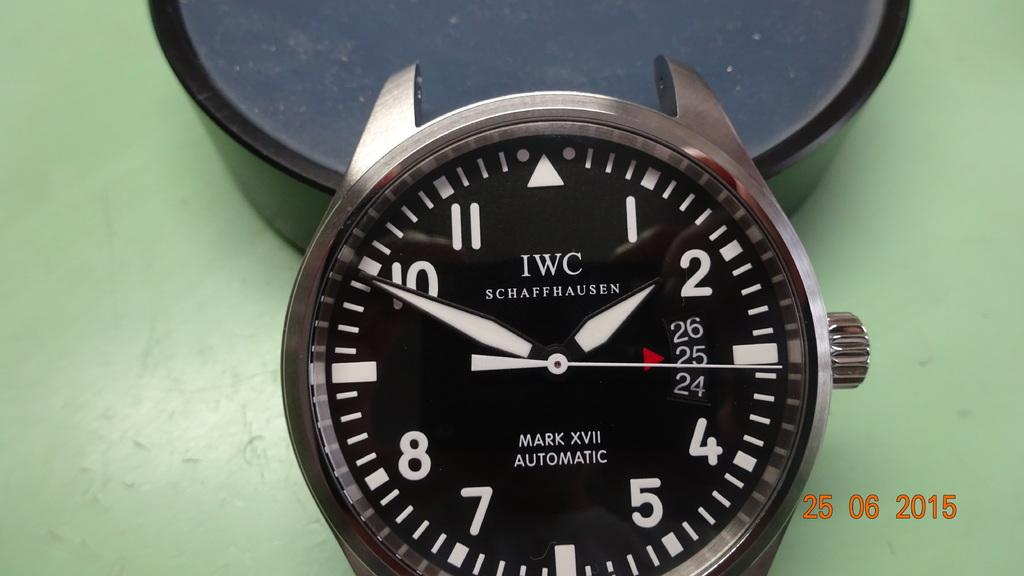<image>
Create a compact narrative representing the image presented. A black and white IWC branded wrist watch sitting in a green background. 